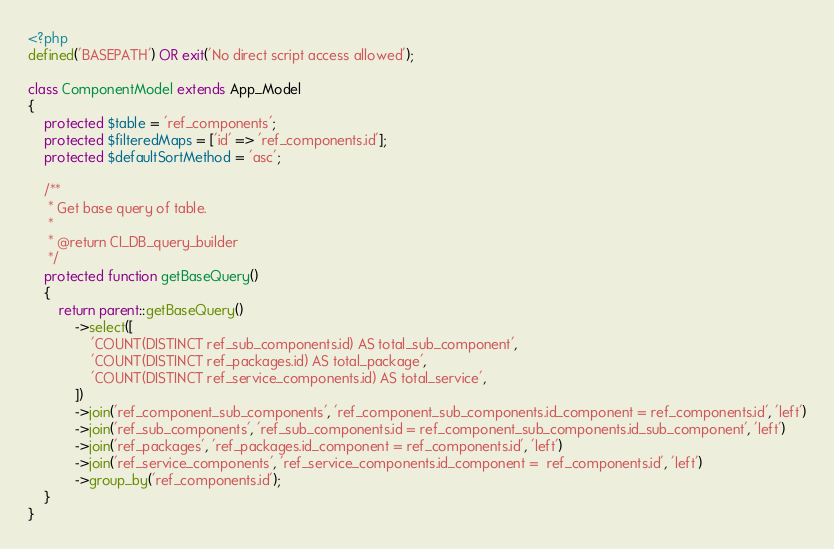Convert code to text. <code><loc_0><loc_0><loc_500><loc_500><_PHP_><?php
defined('BASEPATH') OR exit('No direct script access allowed');

class ComponentModel extends App_Model
{
    protected $table = 'ref_components';
    protected $filteredMaps = ['id' => 'ref_components.id'];
    protected $defaultSortMethod = 'asc';

    /**
     * Get base query of table.
     *
     * @return CI_DB_query_builder
     */
    protected function getBaseQuery()
    {
        return parent::getBaseQuery()
            ->select([
                'COUNT(DISTINCT ref_sub_components.id) AS total_sub_component',
                'COUNT(DISTINCT ref_packages.id) AS total_package',
                'COUNT(DISTINCT ref_service_components.id) AS total_service',
            ])
            ->join('ref_component_sub_components', 'ref_component_sub_components.id_component = ref_components.id', 'left')
            ->join('ref_sub_components', 'ref_sub_components.id = ref_component_sub_components.id_sub_component', 'left')
            ->join('ref_packages', 'ref_packages.id_component = ref_components.id', 'left')
            ->join('ref_service_components', 'ref_service_components.id_component =  ref_components.id', 'left')
            ->group_by('ref_components.id');
    }
}
</code> 